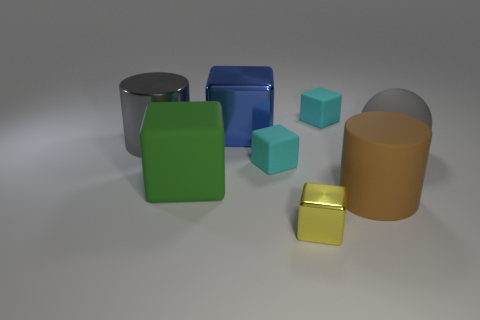Subtract all green blocks. How many blocks are left? 4 Add 1 big brown cylinders. How many objects exist? 9 Subtract all cyan cubes. How many cubes are left? 3 Subtract 1 balls. How many balls are left? 0 Subtract all blocks. How many objects are left? 3 Add 5 small metallic objects. How many small metallic objects are left? 6 Add 5 green rubber objects. How many green rubber objects exist? 6 Subtract 1 gray cylinders. How many objects are left? 7 Subtract all red cylinders. Subtract all brown cubes. How many cylinders are left? 2 Subtract all purple cylinders. How many yellow blocks are left? 1 